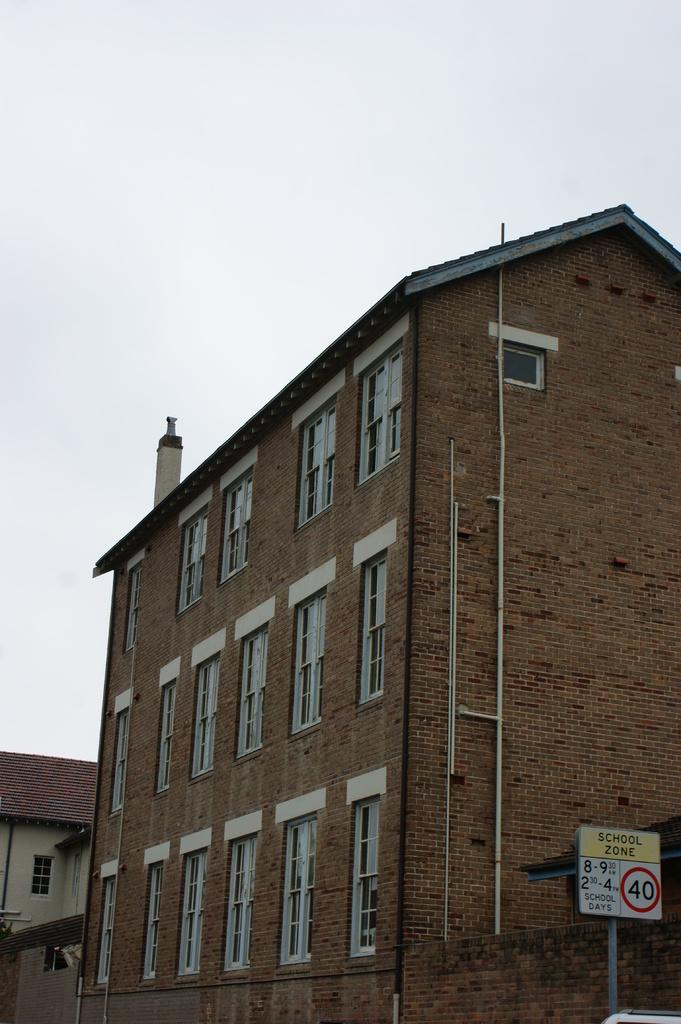What type of structures can be seen in the image? There are buildings in the image. What part of the natural environment is visible in the image? The sky is visible in the background of the image. What type of creature can be seen playing in the park in the image? There is no park or creature present in the image; it only features buildings and the sky. 